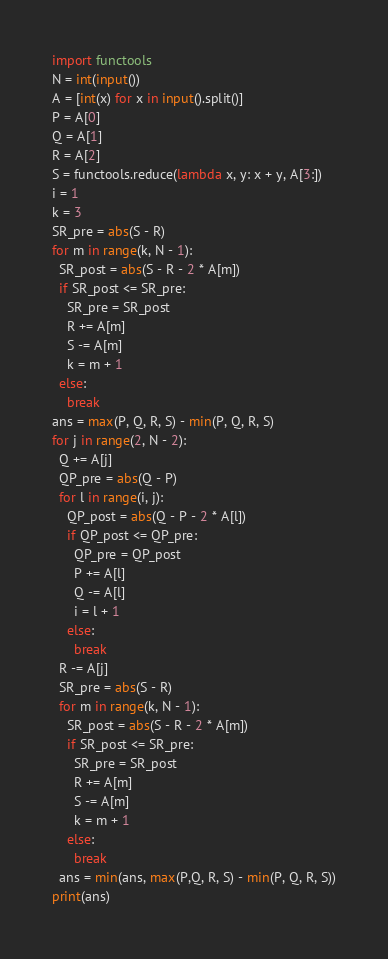<code> <loc_0><loc_0><loc_500><loc_500><_Python_>import functools
N = int(input())
A = [int(x) for x in input().split()]
P = A[0]
Q = A[1]
R = A[2]
S = functools.reduce(lambda x, y: x + y, A[3:])
i = 1
k = 3
SR_pre = abs(S - R)
for m in range(k, N - 1):
  SR_post = abs(S - R - 2 * A[m])
  if SR_post <= SR_pre:
    SR_pre = SR_post
    R += A[m]
    S -= A[m]
    k = m + 1
  else:
    break
ans = max(P, Q, R, S) - min(P, Q, R, S)
for j in range(2, N - 2):
  Q += A[j]
  QP_pre = abs(Q - P)
  for l in range(i, j):
    QP_post = abs(Q - P - 2 * A[l])
    if QP_post <= QP_pre:
      QP_pre = QP_post
      P += A[l]
      Q -= A[l]
      i = l + 1
    else:
      break
  R -= A[j]
  SR_pre = abs(S - R)
  for m in range(k, N - 1):
    SR_post = abs(S - R - 2 * A[m])
    if SR_post <= SR_pre:
      SR_pre = SR_post
      R += A[m]
      S -= A[m]
      k = m + 1
    else:
      break
  ans = min(ans, max(P,Q, R, S) - min(P, Q, R, S))
print(ans)</code> 